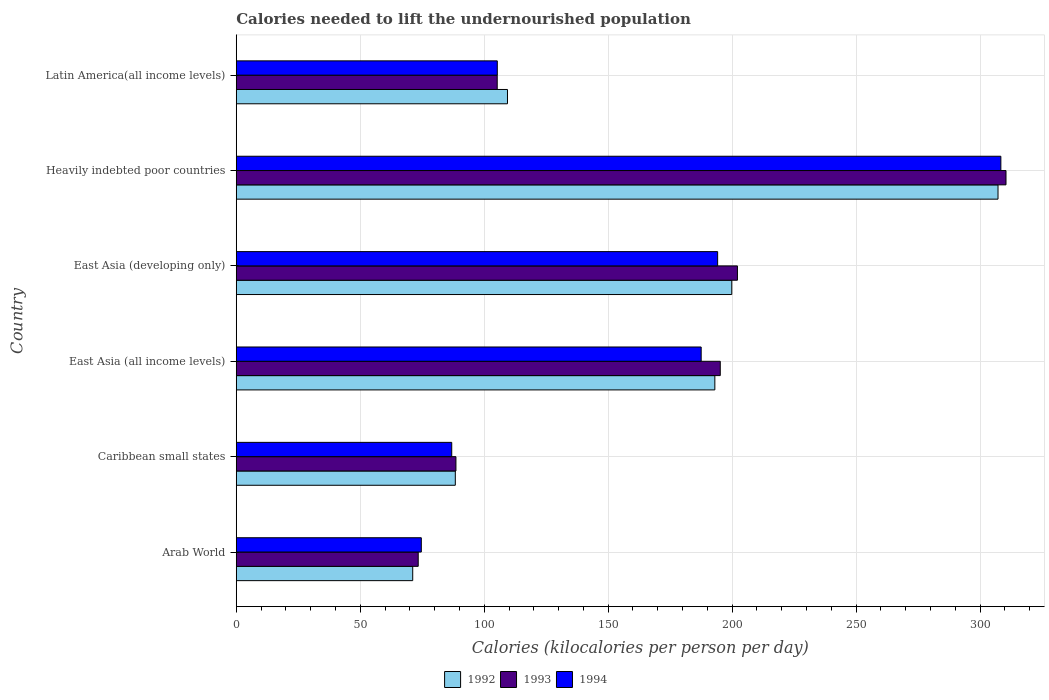Are the number of bars per tick equal to the number of legend labels?
Make the answer very short. Yes. How many bars are there on the 6th tick from the bottom?
Ensure brevity in your answer.  3. What is the label of the 5th group of bars from the top?
Your response must be concise. Caribbean small states. What is the total calories needed to lift the undernourished population in 1993 in East Asia (developing only)?
Ensure brevity in your answer.  202.13. Across all countries, what is the maximum total calories needed to lift the undernourished population in 1994?
Keep it short and to the point. 308.37. Across all countries, what is the minimum total calories needed to lift the undernourished population in 1992?
Offer a terse response. 71.17. In which country was the total calories needed to lift the undernourished population in 1994 maximum?
Your answer should be compact. Heavily indebted poor countries. In which country was the total calories needed to lift the undernourished population in 1992 minimum?
Your response must be concise. Arab World. What is the total total calories needed to lift the undernourished population in 1994 in the graph?
Offer a very short reply. 956.84. What is the difference between the total calories needed to lift the undernourished population in 1994 in Caribbean small states and that in Latin America(all income levels)?
Offer a very short reply. -18.37. What is the difference between the total calories needed to lift the undernourished population in 1994 in Heavily indebted poor countries and the total calories needed to lift the undernourished population in 1992 in Arab World?
Make the answer very short. 237.2. What is the average total calories needed to lift the undernourished population in 1994 per country?
Your answer should be very brief. 159.47. What is the difference between the total calories needed to lift the undernourished population in 1992 and total calories needed to lift the undernourished population in 1994 in East Asia (all income levels)?
Give a very brief answer. 5.51. In how many countries, is the total calories needed to lift the undernourished population in 1992 greater than 110 kilocalories?
Provide a succinct answer. 3. What is the ratio of the total calories needed to lift the undernourished population in 1994 in Caribbean small states to that in Heavily indebted poor countries?
Your response must be concise. 0.28. Is the total calories needed to lift the undernourished population in 1994 in Heavily indebted poor countries less than that in Latin America(all income levels)?
Give a very brief answer. No. Is the difference between the total calories needed to lift the undernourished population in 1992 in East Asia (developing only) and Heavily indebted poor countries greater than the difference between the total calories needed to lift the undernourished population in 1994 in East Asia (developing only) and Heavily indebted poor countries?
Your answer should be compact. Yes. What is the difference between the highest and the second highest total calories needed to lift the undernourished population in 1993?
Your answer should be compact. 108.31. What is the difference between the highest and the lowest total calories needed to lift the undernourished population in 1992?
Your response must be concise. 236.05. In how many countries, is the total calories needed to lift the undernourished population in 1992 greater than the average total calories needed to lift the undernourished population in 1992 taken over all countries?
Offer a terse response. 3. What does the 3rd bar from the top in Arab World represents?
Your answer should be very brief. 1992. What does the 2nd bar from the bottom in East Asia (developing only) represents?
Your answer should be compact. 1993. Are all the bars in the graph horizontal?
Your answer should be very brief. Yes. How many countries are there in the graph?
Offer a terse response. 6. Where does the legend appear in the graph?
Offer a very short reply. Bottom center. What is the title of the graph?
Keep it short and to the point. Calories needed to lift the undernourished population. What is the label or title of the X-axis?
Offer a terse response. Calories (kilocalories per person per day). What is the label or title of the Y-axis?
Your answer should be very brief. Country. What is the Calories (kilocalories per person per day) of 1992 in Arab World?
Your response must be concise. 71.17. What is the Calories (kilocalories per person per day) in 1993 in Arab World?
Make the answer very short. 73.39. What is the Calories (kilocalories per person per day) in 1994 in Arab World?
Offer a very short reply. 74.63. What is the Calories (kilocalories per person per day) in 1992 in Caribbean small states?
Your response must be concise. 88.35. What is the Calories (kilocalories per person per day) of 1993 in Caribbean small states?
Your answer should be very brief. 88.6. What is the Calories (kilocalories per person per day) in 1994 in Caribbean small states?
Your answer should be compact. 86.9. What is the Calories (kilocalories per person per day) of 1992 in East Asia (all income levels)?
Your answer should be compact. 193.02. What is the Calories (kilocalories per person per day) in 1993 in East Asia (all income levels)?
Provide a short and direct response. 195.2. What is the Calories (kilocalories per person per day) of 1994 in East Asia (all income levels)?
Your response must be concise. 187.51. What is the Calories (kilocalories per person per day) in 1992 in East Asia (developing only)?
Offer a very short reply. 199.84. What is the Calories (kilocalories per person per day) of 1993 in East Asia (developing only)?
Provide a succinct answer. 202.13. What is the Calories (kilocalories per person per day) in 1994 in East Asia (developing only)?
Offer a very short reply. 194.15. What is the Calories (kilocalories per person per day) of 1992 in Heavily indebted poor countries?
Make the answer very short. 307.23. What is the Calories (kilocalories per person per day) of 1993 in Heavily indebted poor countries?
Make the answer very short. 310.45. What is the Calories (kilocalories per person per day) of 1994 in Heavily indebted poor countries?
Offer a terse response. 308.37. What is the Calories (kilocalories per person per day) in 1992 in Latin America(all income levels)?
Make the answer very short. 109.39. What is the Calories (kilocalories per person per day) in 1993 in Latin America(all income levels)?
Offer a terse response. 105.25. What is the Calories (kilocalories per person per day) in 1994 in Latin America(all income levels)?
Your answer should be compact. 105.28. Across all countries, what is the maximum Calories (kilocalories per person per day) of 1992?
Offer a terse response. 307.23. Across all countries, what is the maximum Calories (kilocalories per person per day) in 1993?
Give a very brief answer. 310.45. Across all countries, what is the maximum Calories (kilocalories per person per day) of 1994?
Offer a very short reply. 308.37. Across all countries, what is the minimum Calories (kilocalories per person per day) in 1992?
Offer a terse response. 71.17. Across all countries, what is the minimum Calories (kilocalories per person per day) in 1993?
Provide a short and direct response. 73.39. Across all countries, what is the minimum Calories (kilocalories per person per day) in 1994?
Provide a succinct answer. 74.63. What is the total Calories (kilocalories per person per day) of 1992 in the graph?
Provide a short and direct response. 969. What is the total Calories (kilocalories per person per day) of 1993 in the graph?
Provide a short and direct response. 975.02. What is the total Calories (kilocalories per person per day) in 1994 in the graph?
Offer a terse response. 956.84. What is the difference between the Calories (kilocalories per person per day) in 1992 in Arab World and that in Caribbean small states?
Offer a terse response. -17.17. What is the difference between the Calories (kilocalories per person per day) in 1993 in Arab World and that in Caribbean small states?
Ensure brevity in your answer.  -15.21. What is the difference between the Calories (kilocalories per person per day) in 1994 in Arab World and that in Caribbean small states?
Give a very brief answer. -12.27. What is the difference between the Calories (kilocalories per person per day) of 1992 in Arab World and that in East Asia (all income levels)?
Offer a very short reply. -121.85. What is the difference between the Calories (kilocalories per person per day) in 1993 in Arab World and that in East Asia (all income levels)?
Give a very brief answer. -121.82. What is the difference between the Calories (kilocalories per person per day) in 1994 in Arab World and that in East Asia (all income levels)?
Offer a very short reply. -112.87. What is the difference between the Calories (kilocalories per person per day) in 1992 in Arab World and that in East Asia (developing only)?
Your response must be concise. -128.67. What is the difference between the Calories (kilocalories per person per day) in 1993 in Arab World and that in East Asia (developing only)?
Give a very brief answer. -128.74. What is the difference between the Calories (kilocalories per person per day) in 1994 in Arab World and that in East Asia (developing only)?
Keep it short and to the point. -119.51. What is the difference between the Calories (kilocalories per person per day) of 1992 in Arab World and that in Heavily indebted poor countries?
Provide a short and direct response. -236.05. What is the difference between the Calories (kilocalories per person per day) in 1993 in Arab World and that in Heavily indebted poor countries?
Give a very brief answer. -237.06. What is the difference between the Calories (kilocalories per person per day) in 1994 in Arab World and that in Heavily indebted poor countries?
Give a very brief answer. -233.73. What is the difference between the Calories (kilocalories per person per day) in 1992 in Arab World and that in Latin America(all income levels)?
Make the answer very short. -38.22. What is the difference between the Calories (kilocalories per person per day) in 1993 in Arab World and that in Latin America(all income levels)?
Your answer should be very brief. -31.86. What is the difference between the Calories (kilocalories per person per day) of 1994 in Arab World and that in Latin America(all income levels)?
Offer a terse response. -30.64. What is the difference between the Calories (kilocalories per person per day) of 1992 in Caribbean small states and that in East Asia (all income levels)?
Provide a succinct answer. -104.67. What is the difference between the Calories (kilocalories per person per day) of 1993 in Caribbean small states and that in East Asia (all income levels)?
Offer a very short reply. -106.61. What is the difference between the Calories (kilocalories per person per day) in 1994 in Caribbean small states and that in East Asia (all income levels)?
Your answer should be very brief. -100.6. What is the difference between the Calories (kilocalories per person per day) in 1992 in Caribbean small states and that in East Asia (developing only)?
Keep it short and to the point. -111.5. What is the difference between the Calories (kilocalories per person per day) of 1993 in Caribbean small states and that in East Asia (developing only)?
Your answer should be compact. -113.53. What is the difference between the Calories (kilocalories per person per day) in 1994 in Caribbean small states and that in East Asia (developing only)?
Give a very brief answer. -107.24. What is the difference between the Calories (kilocalories per person per day) of 1992 in Caribbean small states and that in Heavily indebted poor countries?
Your answer should be compact. -218.88. What is the difference between the Calories (kilocalories per person per day) of 1993 in Caribbean small states and that in Heavily indebted poor countries?
Provide a short and direct response. -221.85. What is the difference between the Calories (kilocalories per person per day) in 1994 in Caribbean small states and that in Heavily indebted poor countries?
Keep it short and to the point. -221.46. What is the difference between the Calories (kilocalories per person per day) of 1992 in Caribbean small states and that in Latin America(all income levels)?
Your response must be concise. -21.04. What is the difference between the Calories (kilocalories per person per day) of 1993 in Caribbean small states and that in Latin America(all income levels)?
Keep it short and to the point. -16.65. What is the difference between the Calories (kilocalories per person per day) in 1994 in Caribbean small states and that in Latin America(all income levels)?
Give a very brief answer. -18.37. What is the difference between the Calories (kilocalories per person per day) in 1992 in East Asia (all income levels) and that in East Asia (developing only)?
Provide a short and direct response. -6.83. What is the difference between the Calories (kilocalories per person per day) in 1993 in East Asia (all income levels) and that in East Asia (developing only)?
Ensure brevity in your answer.  -6.93. What is the difference between the Calories (kilocalories per person per day) of 1994 in East Asia (all income levels) and that in East Asia (developing only)?
Provide a succinct answer. -6.64. What is the difference between the Calories (kilocalories per person per day) in 1992 in East Asia (all income levels) and that in Heavily indebted poor countries?
Your response must be concise. -114.21. What is the difference between the Calories (kilocalories per person per day) in 1993 in East Asia (all income levels) and that in Heavily indebted poor countries?
Keep it short and to the point. -115.24. What is the difference between the Calories (kilocalories per person per day) of 1994 in East Asia (all income levels) and that in Heavily indebted poor countries?
Make the answer very short. -120.86. What is the difference between the Calories (kilocalories per person per day) of 1992 in East Asia (all income levels) and that in Latin America(all income levels)?
Give a very brief answer. 83.63. What is the difference between the Calories (kilocalories per person per day) in 1993 in East Asia (all income levels) and that in Latin America(all income levels)?
Offer a very short reply. 89.96. What is the difference between the Calories (kilocalories per person per day) of 1994 in East Asia (all income levels) and that in Latin America(all income levels)?
Your answer should be compact. 82.23. What is the difference between the Calories (kilocalories per person per day) of 1992 in East Asia (developing only) and that in Heavily indebted poor countries?
Offer a terse response. -107.38. What is the difference between the Calories (kilocalories per person per day) of 1993 in East Asia (developing only) and that in Heavily indebted poor countries?
Offer a very short reply. -108.31. What is the difference between the Calories (kilocalories per person per day) of 1994 in East Asia (developing only) and that in Heavily indebted poor countries?
Keep it short and to the point. -114.22. What is the difference between the Calories (kilocalories per person per day) in 1992 in East Asia (developing only) and that in Latin America(all income levels)?
Keep it short and to the point. 90.45. What is the difference between the Calories (kilocalories per person per day) in 1993 in East Asia (developing only) and that in Latin America(all income levels)?
Offer a very short reply. 96.88. What is the difference between the Calories (kilocalories per person per day) of 1994 in East Asia (developing only) and that in Latin America(all income levels)?
Make the answer very short. 88.87. What is the difference between the Calories (kilocalories per person per day) in 1992 in Heavily indebted poor countries and that in Latin America(all income levels)?
Your answer should be compact. 197.84. What is the difference between the Calories (kilocalories per person per day) in 1993 in Heavily indebted poor countries and that in Latin America(all income levels)?
Your answer should be compact. 205.2. What is the difference between the Calories (kilocalories per person per day) in 1994 in Heavily indebted poor countries and that in Latin America(all income levels)?
Provide a short and direct response. 203.09. What is the difference between the Calories (kilocalories per person per day) of 1992 in Arab World and the Calories (kilocalories per person per day) of 1993 in Caribbean small states?
Your answer should be compact. -17.43. What is the difference between the Calories (kilocalories per person per day) of 1992 in Arab World and the Calories (kilocalories per person per day) of 1994 in Caribbean small states?
Ensure brevity in your answer.  -15.73. What is the difference between the Calories (kilocalories per person per day) of 1993 in Arab World and the Calories (kilocalories per person per day) of 1994 in Caribbean small states?
Offer a very short reply. -13.51. What is the difference between the Calories (kilocalories per person per day) of 1992 in Arab World and the Calories (kilocalories per person per day) of 1993 in East Asia (all income levels)?
Provide a succinct answer. -124.03. What is the difference between the Calories (kilocalories per person per day) of 1992 in Arab World and the Calories (kilocalories per person per day) of 1994 in East Asia (all income levels)?
Keep it short and to the point. -116.34. What is the difference between the Calories (kilocalories per person per day) of 1993 in Arab World and the Calories (kilocalories per person per day) of 1994 in East Asia (all income levels)?
Provide a short and direct response. -114.12. What is the difference between the Calories (kilocalories per person per day) of 1992 in Arab World and the Calories (kilocalories per person per day) of 1993 in East Asia (developing only)?
Your answer should be very brief. -130.96. What is the difference between the Calories (kilocalories per person per day) in 1992 in Arab World and the Calories (kilocalories per person per day) in 1994 in East Asia (developing only)?
Give a very brief answer. -122.97. What is the difference between the Calories (kilocalories per person per day) in 1993 in Arab World and the Calories (kilocalories per person per day) in 1994 in East Asia (developing only)?
Your response must be concise. -120.76. What is the difference between the Calories (kilocalories per person per day) in 1992 in Arab World and the Calories (kilocalories per person per day) in 1993 in Heavily indebted poor countries?
Give a very brief answer. -239.27. What is the difference between the Calories (kilocalories per person per day) in 1992 in Arab World and the Calories (kilocalories per person per day) in 1994 in Heavily indebted poor countries?
Your answer should be very brief. -237.2. What is the difference between the Calories (kilocalories per person per day) in 1993 in Arab World and the Calories (kilocalories per person per day) in 1994 in Heavily indebted poor countries?
Make the answer very short. -234.98. What is the difference between the Calories (kilocalories per person per day) of 1992 in Arab World and the Calories (kilocalories per person per day) of 1993 in Latin America(all income levels)?
Provide a short and direct response. -34.08. What is the difference between the Calories (kilocalories per person per day) in 1992 in Arab World and the Calories (kilocalories per person per day) in 1994 in Latin America(all income levels)?
Ensure brevity in your answer.  -34.11. What is the difference between the Calories (kilocalories per person per day) in 1993 in Arab World and the Calories (kilocalories per person per day) in 1994 in Latin America(all income levels)?
Give a very brief answer. -31.89. What is the difference between the Calories (kilocalories per person per day) in 1992 in Caribbean small states and the Calories (kilocalories per person per day) in 1993 in East Asia (all income levels)?
Ensure brevity in your answer.  -106.86. What is the difference between the Calories (kilocalories per person per day) in 1992 in Caribbean small states and the Calories (kilocalories per person per day) in 1994 in East Asia (all income levels)?
Provide a succinct answer. -99.16. What is the difference between the Calories (kilocalories per person per day) of 1993 in Caribbean small states and the Calories (kilocalories per person per day) of 1994 in East Asia (all income levels)?
Provide a short and direct response. -98.91. What is the difference between the Calories (kilocalories per person per day) in 1992 in Caribbean small states and the Calories (kilocalories per person per day) in 1993 in East Asia (developing only)?
Keep it short and to the point. -113.79. What is the difference between the Calories (kilocalories per person per day) in 1992 in Caribbean small states and the Calories (kilocalories per person per day) in 1994 in East Asia (developing only)?
Provide a short and direct response. -105.8. What is the difference between the Calories (kilocalories per person per day) of 1993 in Caribbean small states and the Calories (kilocalories per person per day) of 1994 in East Asia (developing only)?
Make the answer very short. -105.55. What is the difference between the Calories (kilocalories per person per day) of 1992 in Caribbean small states and the Calories (kilocalories per person per day) of 1993 in Heavily indebted poor countries?
Make the answer very short. -222.1. What is the difference between the Calories (kilocalories per person per day) in 1992 in Caribbean small states and the Calories (kilocalories per person per day) in 1994 in Heavily indebted poor countries?
Your answer should be very brief. -220.02. What is the difference between the Calories (kilocalories per person per day) of 1993 in Caribbean small states and the Calories (kilocalories per person per day) of 1994 in Heavily indebted poor countries?
Provide a short and direct response. -219.77. What is the difference between the Calories (kilocalories per person per day) in 1992 in Caribbean small states and the Calories (kilocalories per person per day) in 1993 in Latin America(all income levels)?
Keep it short and to the point. -16.9. What is the difference between the Calories (kilocalories per person per day) of 1992 in Caribbean small states and the Calories (kilocalories per person per day) of 1994 in Latin America(all income levels)?
Keep it short and to the point. -16.93. What is the difference between the Calories (kilocalories per person per day) in 1993 in Caribbean small states and the Calories (kilocalories per person per day) in 1994 in Latin America(all income levels)?
Your answer should be compact. -16.68. What is the difference between the Calories (kilocalories per person per day) of 1992 in East Asia (all income levels) and the Calories (kilocalories per person per day) of 1993 in East Asia (developing only)?
Your answer should be compact. -9.11. What is the difference between the Calories (kilocalories per person per day) of 1992 in East Asia (all income levels) and the Calories (kilocalories per person per day) of 1994 in East Asia (developing only)?
Offer a terse response. -1.13. What is the difference between the Calories (kilocalories per person per day) of 1993 in East Asia (all income levels) and the Calories (kilocalories per person per day) of 1994 in East Asia (developing only)?
Your answer should be very brief. 1.06. What is the difference between the Calories (kilocalories per person per day) of 1992 in East Asia (all income levels) and the Calories (kilocalories per person per day) of 1993 in Heavily indebted poor countries?
Make the answer very short. -117.43. What is the difference between the Calories (kilocalories per person per day) in 1992 in East Asia (all income levels) and the Calories (kilocalories per person per day) in 1994 in Heavily indebted poor countries?
Your response must be concise. -115.35. What is the difference between the Calories (kilocalories per person per day) of 1993 in East Asia (all income levels) and the Calories (kilocalories per person per day) of 1994 in Heavily indebted poor countries?
Your answer should be very brief. -113.16. What is the difference between the Calories (kilocalories per person per day) of 1992 in East Asia (all income levels) and the Calories (kilocalories per person per day) of 1993 in Latin America(all income levels)?
Ensure brevity in your answer.  87.77. What is the difference between the Calories (kilocalories per person per day) in 1992 in East Asia (all income levels) and the Calories (kilocalories per person per day) in 1994 in Latin America(all income levels)?
Ensure brevity in your answer.  87.74. What is the difference between the Calories (kilocalories per person per day) in 1993 in East Asia (all income levels) and the Calories (kilocalories per person per day) in 1994 in Latin America(all income levels)?
Offer a very short reply. 89.93. What is the difference between the Calories (kilocalories per person per day) in 1992 in East Asia (developing only) and the Calories (kilocalories per person per day) in 1993 in Heavily indebted poor countries?
Provide a short and direct response. -110.6. What is the difference between the Calories (kilocalories per person per day) of 1992 in East Asia (developing only) and the Calories (kilocalories per person per day) of 1994 in Heavily indebted poor countries?
Offer a terse response. -108.52. What is the difference between the Calories (kilocalories per person per day) of 1993 in East Asia (developing only) and the Calories (kilocalories per person per day) of 1994 in Heavily indebted poor countries?
Ensure brevity in your answer.  -106.24. What is the difference between the Calories (kilocalories per person per day) of 1992 in East Asia (developing only) and the Calories (kilocalories per person per day) of 1993 in Latin America(all income levels)?
Your answer should be very brief. 94.6. What is the difference between the Calories (kilocalories per person per day) of 1992 in East Asia (developing only) and the Calories (kilocalories per person per day) of 1994 in Latin America(all income levels)?
Ensure brevity in your answer.  94.57. What is the difference between the Calories (kilocalories per person per day) of 1993 in East Asia (developing only) and the Calories (kilocalories per person per day) of 1994 in Latin America(all income levels)?
Provide a short and direct response. 96.85. What is the difference between the Calories (kilocalories per person per day) of 1992 in Heavily indebted poor countries and the Calories (kilocalories per person per day) of 1993 in Latin America(all income levels)?
Provide a succinct answer. 201.98. What is the difference between the Calories (kilocalories per person per day) in 1992 in Heavily indebted poor countries and the Calories (kilocalories per person per day) in 1994 in Latin America(all income levels)?
Your answer should be compact. 201.95. What is the difference between the Calories (kilocalories per person per day) in 1993 in Heavily indebted poor countries and the Calories (kilocalories per person per day) in 1994 in Latin America(all income levels)?
Offer a terse response. 205.17. What is the average Calories (kilocalories per person per day) in 1992 per country?
Give a very brief answer. 161.5. What is the average Calories (kilocalories per person per day) in 1993 per country?
Your answer should be very brief. 162.5. What is the average Calories (kilocalories per person per day) of 1994 per country?
Ensure brevity in your answer.  159.47. What is the difference between the Calories (kilocalories per person per day) of 1992 and Calories (kilocalories per person per day) of 1993 in Arab World?
Offer a very short reply. -2.22. What is the difference between the Calories (kilocalories per person per day) of 1992 and Calories (kilocalories per person per day) of 1994 in Arab World?
Offer a terse response. -3.46. What is the difference between the Calories (kilocalories per person per day) of 1993 and Calories (kilocalories per person per day) of 1994 in Arab World?
Provide a succinct answer. -1.24. What is the difference between the Calories (kilocalories per person per day) of 1992 and Calories (kilocalories per person per day) of 1993 in Caribbean small states?
Offer a terse response. -0.25. What is the difference between the Calories (kilocalories per person per day) in 1992 and Calories (kilocalories per person per day) in 1994 in Caribbean small states?
Give a very brief answer. 1.44. What is the difference between the Calories (kilocalories per person per day) in 1993 and Calories (kilocalories per person per day) in 1994 in Caribbean small states?
Provide a short and direct response. 1.7. What is the difference between the Calories (kilocalories per person per day) of 1992 and Calories (kilocalories per person per day) of 1993 in East Asia (all income levels)?
Give a very brief answer. -2.19. What is the difference between the Calories (kilocalories per person per day) in 1992 and Calories (kilocalories per person per day) in 1994 in East Asia (all income levels)?
Provide a short and direct response. 5.51. What is the difference between the Calories (kilocalories per person per day) in 1993 and Calories (kilocalories per person per day) in 1994 in East Asia (all income levels)?
Give a very brief answer. 7.7. What is the difference between the Calories (kilocalories per person per day) in 1992 and Calories (kilocalories per person per day) in 1993 in East Asia (developing only)?
Ensure brevity in your answer.  -2.29. What is the difference between the Calories (kilocalories per person per day) of 1992 and Calories (kilocalories per person per day) of 1994 in East Asia (developing only)?
Ensure brevity in your answer.  5.7. What is the difference between the Calories (kilocalories per person per day) of 1993 and Calories (kilocalories per person per day) of 1994 in East Asia (developing only)?
Make the answer very short. 7.99. What is the difference between the Calories (kilocalories per person per day) of 1992 and Calories (kilocalories per person per day) of 1993 in Heavily indebted poor countries?
Make the answer very short. -3.22. What is the difference between the Calories (kilocalories per person per day) in 1992 and Calories (kilocalories per person per day) in 1994 in Heavily indebted poor countries?
Offer a terse response. -1.14. What is the difference between the Calories (kilocalories per person per day) in 1993 and Calories (kilocalories per person per day) in 1994 in Heavily indebted poor countries?
Offer a very short reply. 2.08. What is the difference between the Calories (kilocalories per person per day) in 1992 and Calories (kilocalories per person per day) in 1993 in Latin America(all income levels)?
Your answer should be very brief. 4.14. What is the difference between the Calories (kilocalories per person per day) in 1992 and Calories (kilocalories per person per day) in 1994 in Latin America(all income levels)?
Ensure brevity in your answer.  4.11. What is the difference between the Calories (kilocalories per person per day) in 1993 and Calories (kilocalories per person per day) in 1994 in Latin America(all income levels)?
Offer a very short reply. -0.03. What is the ratio of the Calories (kilocalories per person per day) of 1992 in Arab World to that in Caribbean small states?
Offer a terse response. 0.81. What is the ratio of the Calories (kilocalories per person per day) in 1993 in Arab World to that in Caribbean small states?
Give a very brief answer. 0.83. What is the ratio of the Calories (kilocalories per person per day) of 1994 in Arab World to that in Caribbean small states?
Keep it short and to the point. 0.86. What is the ratio of the Calories (kilocalories per person per day) in 1992 in Arab World to that in East Asia (all income levels)?
Offer a very short reply. 0.37. What is the ratio of the Calories (kilocalories per person per day) in 1993 in Arab World to that in East Asia (all income levels)?
Give a very brief answer. 0.38. What is the ratio of the Calories (kilocalories per person per day) of 1994 in Arab World to that in East Asia (all income levels)?
Keep it short and to the point. 0.4. What is the ratio of the Calories (kilocalories per person per day) of 1992 in Arab World to that in East Asia (developing only)?
Your response must be concise. 0.36. What is the ratio of the Calories (kilocalories per person per day) in 1993 in Arab World to that in East Asia (developing only)?
Ensure brevity in your answer.  0.36. What is the ratio of the Calories (kilocalories per person per day) in 1994 in Arab World to that in East Asia (developing only)?
Offer a terse response. 0.38. What is the ratio of the Calories (kilocalories per person per day) in 1992 in Arab World to that in Heavily indebted poor countries?
Make the answer very short. 0.23. What is the ratio of the Calories (kilocalories per person per day) of 1993 in Arab World to that in Heavily indebted poor countries?
Your answer should be very brief. 0.24. What is the ratio of the Calories (kilocalories per person per day) in 1994 in Arab World to that in Heavily indebted poor countries?
Your answer should be very brief. 0.24. What is the ratio of the Calories (kilocalories per person per day) of 1992 in Arab World to that in Latin America(all income levels)?
Keep it short and to the point. 0.65. What is the ratio of the Calories (kilocalories per person per day) in 1993 in Arab World to that in Latin America(all income levels)?
Offer a very short reply. 0.7. What is the ratio of the Calories (kilocalories per person per day) of 1994 in Arab World to that in Latin America(all income levels)?
Provide a short and direct response. 0.71. What is the ratio of the Calories (kilocalories per person per day) in 1992 in Caribbean small states to that in East Asia (all income levels)?
Make the answer very short. 0.46. What is the ratio of the Calories (kilocalories per person per day) of 1993 in Caribbean small states to that in East Asia (all income levels)?
Ensure brevity in your answer.  0.45. What is the ratio of the Calories (kilocalories per person per day) of 1994 in Caribbean small states to that in East Asia (all income levels)?
Offer a terse response. 0.46. What is the ratio of the Calories (kilocalories per person per day) of 1992 in Caribbean small states to that in East Asia (developing only)?
Offer a terse response. 0.44. What is the ratio of the Calories (kilocalories per person per day) in 1993 in Caribbean small states to that in East Asia (developing only)?
Offer a very short reply. 0.44. What is the ratio of the Calories (kilocalories per person per day) of 1994 in Caribbean small states to that in East Asia (developing only)?
Your response must be concise. 0.45. What is the ratio of the Calories (kilocalories per person per day) in 1992 in Caribbean small states to that in Heavily indebted poor countries?
Make the answer very short. 0.29. What is the ratio of the Calories (kilocalories per person per day) in 1993 in Caribbean small states to that in Heavily indebted poor countries?
Make the answer very short. 0.29. What is the ratio of the Calories (kilocalories per person per day) in 1994 in Caribbean small states to that in Heavily indebted poor countries?
Provide a succinct answer. 0.28. What is the ratio of the Calories (kilocalories per person per day) in 1992 in Caribbean small states to that in Latin America(all income levels)?
Offer a very short reply. 0.81. What is the ratio of the Calories (kilocalories per person per day) of 1993 in Caribbean small states to that in Latin America(all income levels)?
Offer a terse response. 0.84. What is the ratio of the Calories (kilocalories per person per day) of 1994 in Caribbean small states to that in Latin America(all income levels)?
Your answer should be very brief. 0.83. What is the ratio of the Calories (kilocalories per person per day) of 1992 in East Asia (all income levels) to that in East Asia (developing only)?
Provide a succinct answer. 0.97. What is the ratio of the Calories (kilocalories per person per day) in 1993 in East Asia (all income levels) to that in East Asia (developing only)?
Give a very brief answer. 0.97. What is the ratio of the Calories (kilocalories per person per day) of 1994 in East Asia (all income levels) to that in East Asia (developing only)?
Make the answer very short. 0.97. What is the ratio of the Calories (kilocalories per person per day) in 1992 in East Asia (all income levels) to that in Heavily indebted poor countries?
Offer a very short reply. 0.63. What is the ratio of the Calories (kilocalories per person per day) of 1993 in East Asia (all income levels) to that in Heavily indebted poor countries?
Give a very brief answer. 0.63. What is the ratio of the Calories (kilocalories per person per day) of 1994 in East Asia (all income levels) to that in Heavily indebted poor countries?
Your answer should be compact. 0.61. What is the ratio of the Calories (kilocalories per person per day) of 1992 in East Asia (all income levels) to that in Latin America(all income levels)?
Offer a very short reply. 1.76. What is the ratio of the Calories (kilocalories per person per day) in 1993 in East Asia (all income levels) to that in Latin America(all income levels)?
Give a very brief answer. 1.85. What is the ratio of the Calories (kilocalories per person per day) of 1994 in East Asia (all income levels) to that in Latin America(all income levels)?
Provide a short and direct response. 1.78. What is the ratio of the Calories (kilocalories per person per day) of 1992 in East Asia (developing only) to that in Heavily indebted poor countries?
Provide a succinct answer. 0.65. What is the ratio of the Calories (kilocalories per person per day) of 1993 in East Asia (developing only) to that in Heavily indebted poor countries?
Your answer should be compact. 0.65. What is the ratio of the Calories (kilocalories per person per day) in 1994 in East Asia (developing only) to that in Heavily indebted poor countries?
Offer a very short reply. 0.63. What is the ratio of the Calories (kilocalories per person per day) in 1992 in East Asia (developing only) to that in Latin America(all income levels)?
Provide a succinct answer. 1.83. What is the ratio of the Calories (kilocalories per person per day) in 1993 in East Asia (developing only) to that in Latin America(all income levels)?
Provide a succinct answer. 1.92. What is the ratio of the Calories (kilocalories per person per day) in 1994 in East Asia (developing only) to that in Latin America(all income levels)?
Make the answer very short. 1.84. What is the ratio of the Calories (kilocalories per person per day) of 1992 in Heavily indebted poor countries to that in Latin America(all income levels)?
Offer a terse response. 2.81. What is the ratio of the Calories (kilocalories per person per day) of 1993 in Heavily indebted poor countries to that in Latin America(all income levels)?
Provide a short and direct response. 2.95. What is the ratio of the Calories (kilocalories per person per day) of 1994 in Heavily indebted poor countries to that in Latin America(all income levels)?
Provide a succinct answer. 2.93. What is the difference between the highest and the second highest Calories (kilocalories per person per day) in 1992?
Your answer should be very brief. 107.38. What is the difference between the highest and the second highest Calories (kilocalories per person per day) in 1993?
Your response must be concise. 108.31. What is the difference between the highest and the second highest Calories (kilocalories per person per day) of 1994?
Your response must be concise. 114.22. What is the difference between the highest and the lowest Calories (kilocalories per person per day) of 1992?
Give a very brief answer. 236.05. What is the difference between the highest and the lowest Calories (kilocalories per person per day) of 1993?
Keep it short and to the point. 237.06. What is the difference between the highest and the lowest Calories (kilocalories per person per day) of 1994?
Keep it short and to the point. 233.73. 